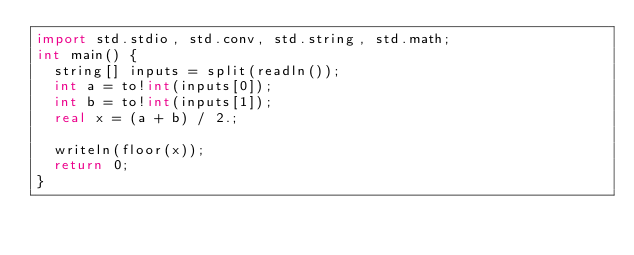<code> <loc_0><loc_0><loc_500><loc_500><_D_>import std.stdio, std.conv, std.string, std.math;
int main() {
  string[] inputs = split(readln());
  int a = to!int(inputs[0]);
  int b = to!int(inputs[1]);
  real x = (a + b) / 2.;
 
  writeln(floor(x));
  return 0;
}</code> 